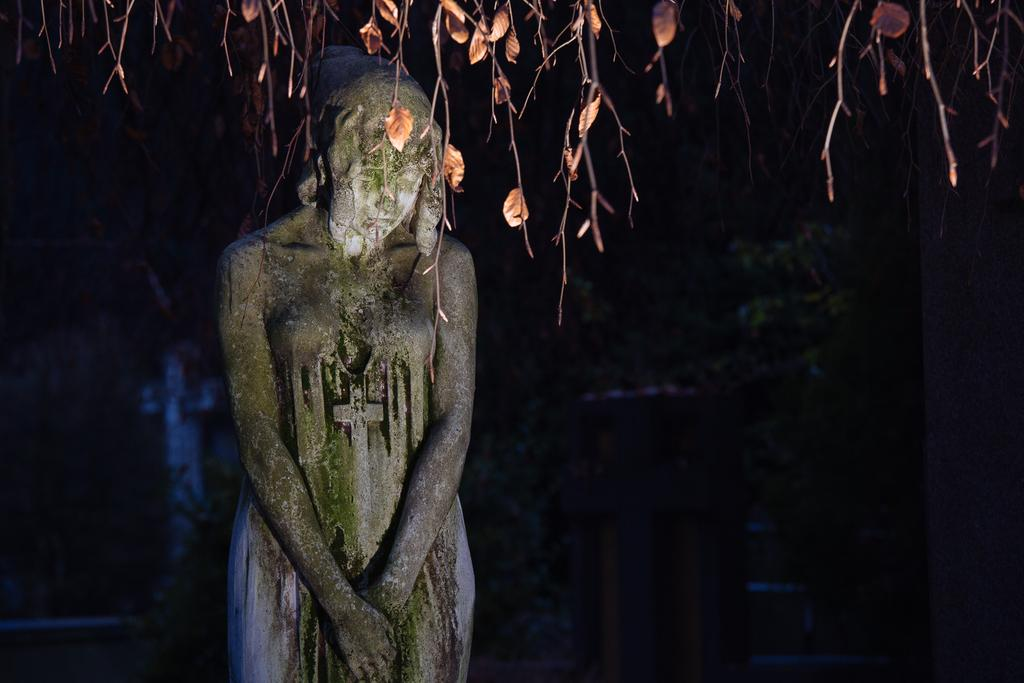What is the main subject of the image? There is a sculpture of a woman standing in the image. What can be seen in the background of the image? The background of the image appears blurry. What type of vegetation is present in the image? There are branches with leaves in the image. How are the branches with leaves positioned? The branches with leaves are hanging. Can you see any toes sticking out of the ocean in the image? There is no ocean present in the image, and therefore no toes sticking out of it. 